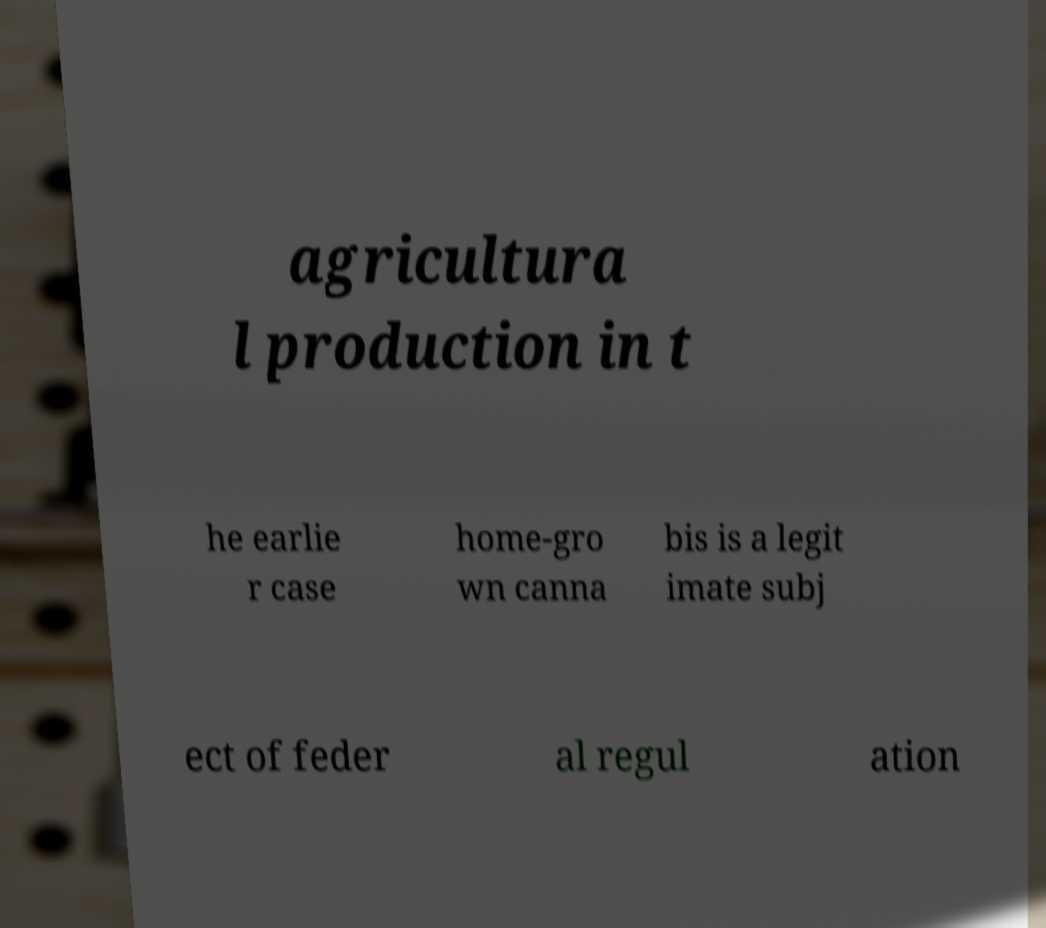Can you read and provide the text displayed in the image?This photo seems to have some interesting text. Can you extract and type it out for me? agricultura l production in t he earlie r case home-gro wn canna bis is a legit imate subj ect of feder al regul ation 